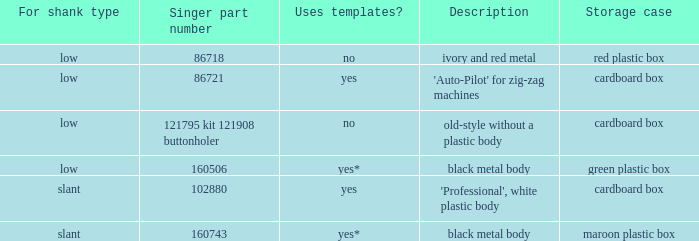What's the description of the buttonholer whose singer part number is 121795 kit 121908 buttonholer? Old-style without a plastic body. 